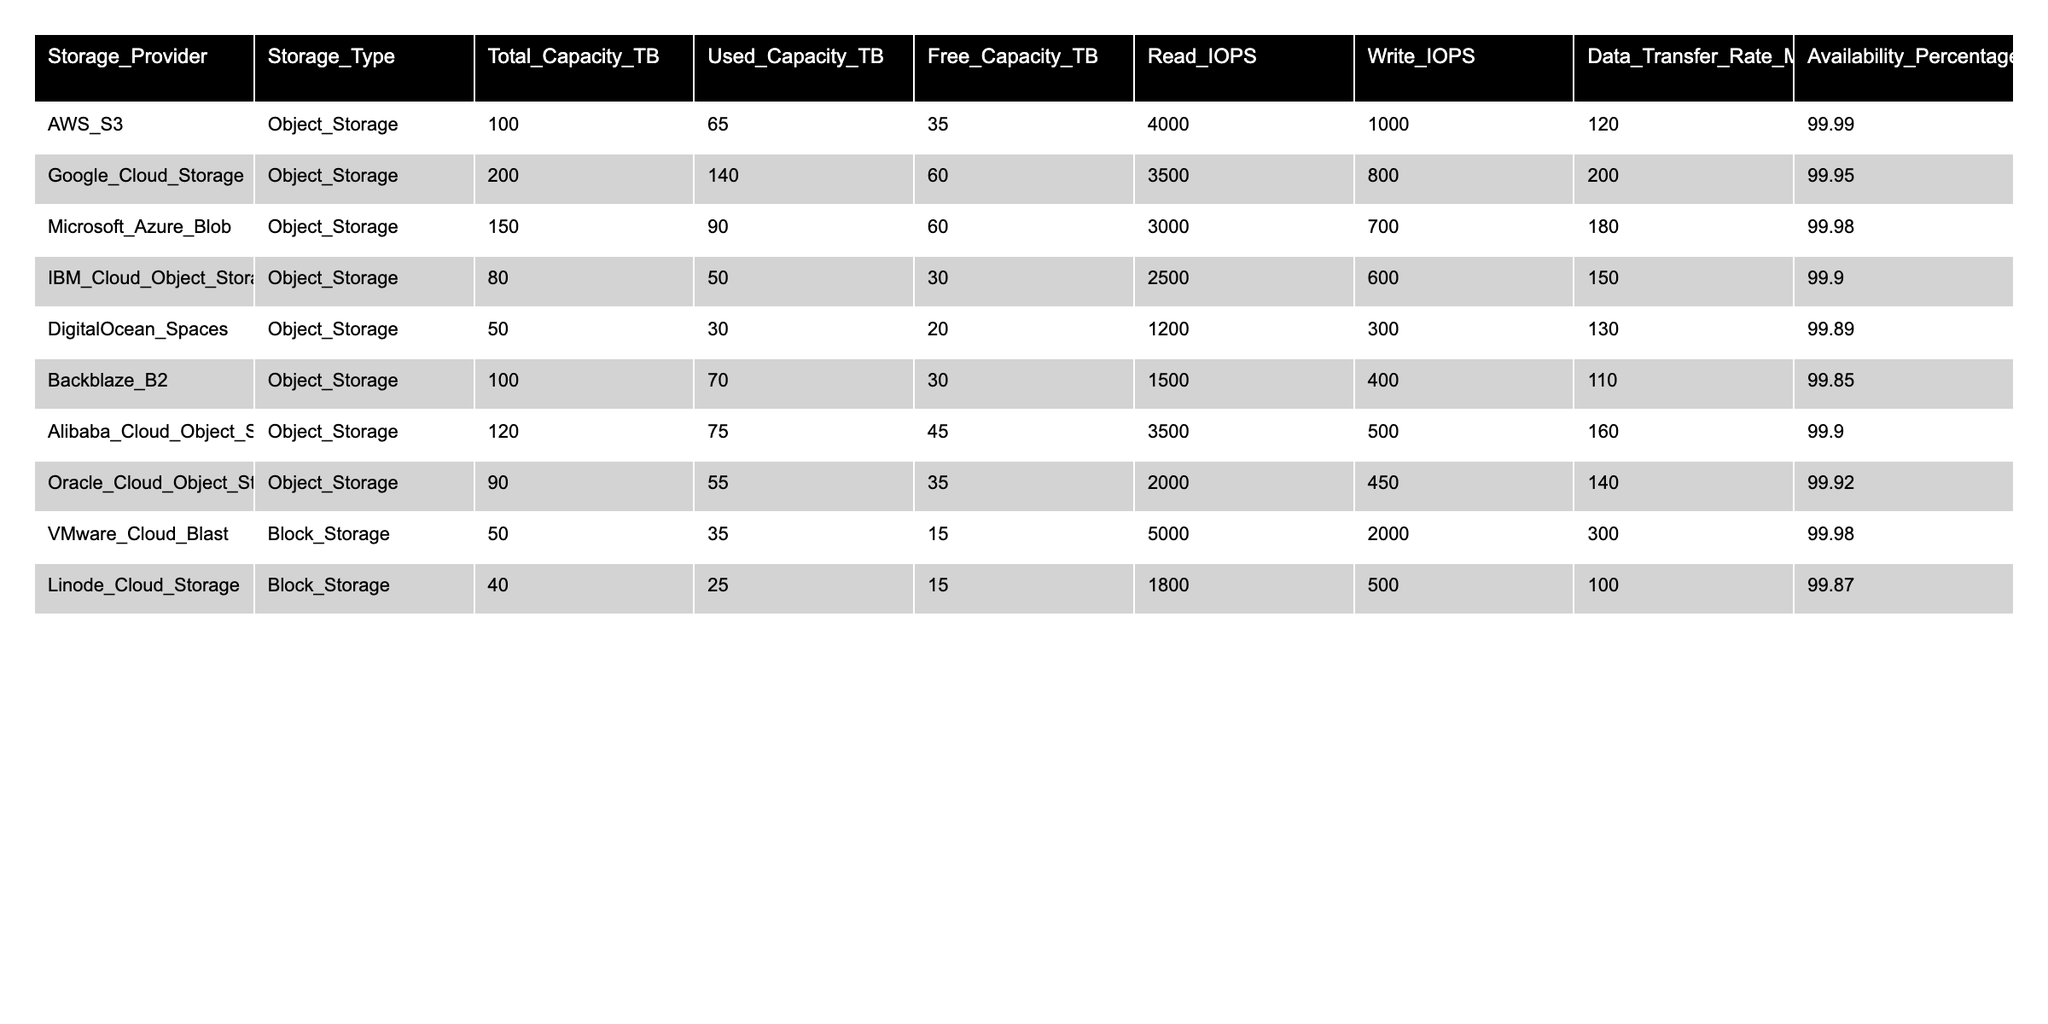What is the total capacity of Google Cloud Storage? The table shows that the total capacity for Google Cloud Storage is 200 TB. This value can be found in the "Total_Capacity_TB" column corresponding to the row for Google Cloud Storage.
Answer: 200 TB Which storage provider has the highest availability percentage? By examining the "Availability_Percentage" column, we see that AWS S3 has the highest availability at 99.99%, as it is the highest value presented in that column.
Answer: AWS S3 What is the total used capacity from all storage providers? To find the total used capacity, we need to sum the values in the "Used_Capacity_TB" column: 65 + 140 + 90 + 50 + 30 + 70 + 75 + 55 + 35 + 25 = 735 TB.
Answer: 735 TB Is the free capacity for DigitalOcean Spaces greater than that for Oracle Cloud Object Storage? DigitalOcean Spaces has 20 TB of free capacity, while Oracle Cloud Object Storage has 35 TB. Since 20 is less than 35, the statement is false.
Answer: No What is the average data transfer rate for block storage solutions? The data transfer rates for block storage providers are 300 MBps for VMware Cloud Blast and 100 MBps for Linode Cloud Storage. To find the average: (300 + 100) / 2 = 200 MBps.
Answer: 200 MBps How much free capacity does Alibaba Cloud Object Storage have compared to Google Cloud Storage? Alibaba Cloud Object Storage has 45 TB of free capacity, and Google Cloud Storage has 60 TB. Since 45 is less than 60, Alibaba's free capacity is lower.
Answer: Lower Which storage provider has the least used capacity among the listed providers? Reviewing the "Used_Capacity_TB" column, the provider with the least used capacity is DigitalOcean Spaces with 30 TB. This is the smallest value in that column.
Answer: DigitalOcean Spaces Calculate the difference in read IOPS between VMware Cloud Blast and Linode Cloud Storage. VMware Cloud Blast has 5000 read IOPS, while Linode Cloud Storage has 1800. The difference is 5000 - 1800 = 3200 IOPS.
Answer: 3200 IOPS Which storage provider has the highest read IOPS, and what is that value? Looking at the "Read_IOPS" column, VMware Cloud Blast has the highest value of 5000 read IOPS, as it is greater than all other entries in that column.
Answer: VMware Cloud Blast, 5000 IOPS If we combine the free capacity of AWS S3 and Backblaze B2, what is the total free capacity? The free capacity of AWS S3 is 35 TB and for Backblaze B2, it is 30 TB. Combined, that equals 35 + 30 = 65 TB.
Answer: 65 TB 